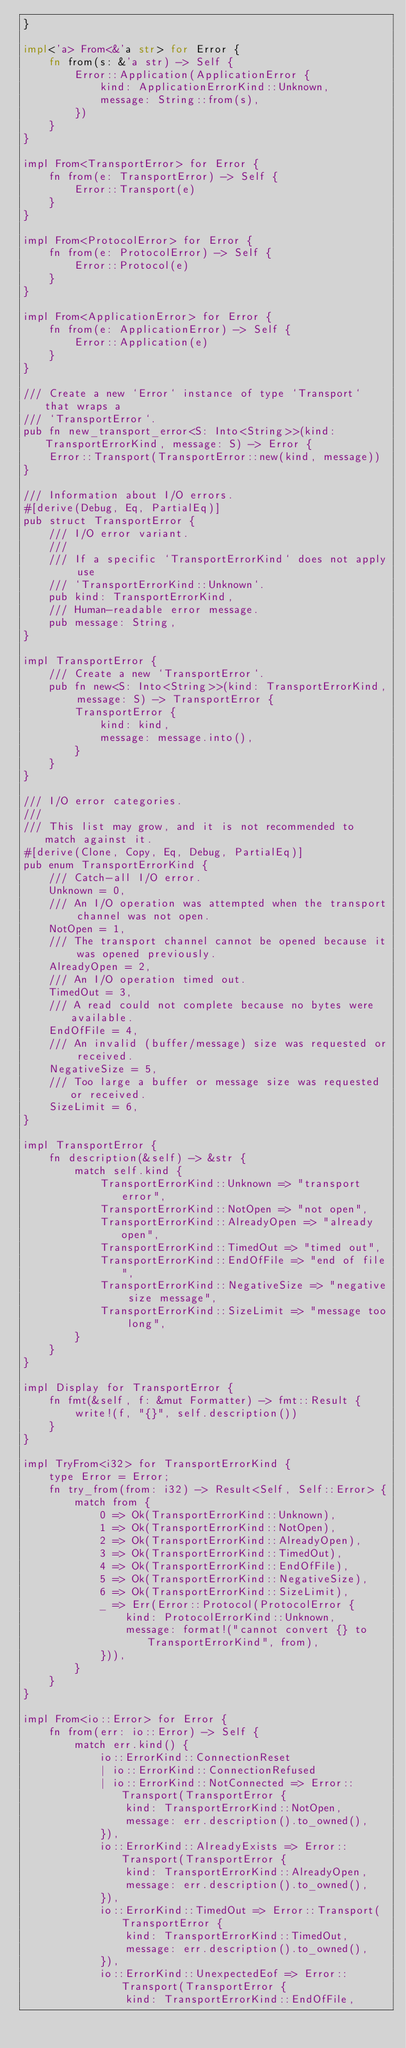<code> <loc_0><loc_0><loc_500><loc_500><_Rust_>}

impl<'a> From<&'a str> for Error {
    fn from(s: &'a str) -> Self {
        Error::Application(ApplicationError {
            kind: ApplicationErrorKind::Unknown,
            message: String::from(s),
        })
    }
}

impl From<TransportError> for Error {
    fn from(e: TransportError) -> Self {
        Error::Transport(e)
    }
}

impl From<ProtocolError> for Error {
    fn from(e: ProtocolError) -> Self {
        Error::Protocol(e)
    }
}

impl From<ApplicationError> for Error {
    fn from(e: ApplicationError) -> Self {
        Error::Application(e)
    }
}

/// Create a new `Error` instance of type `Transport` that wraps a
/// `TransportError`.
pub fn new_transport_error<S: Into<String>>(kind: TransportErrorKind, message: S) -> Error {
    Error::Transport(TransportError::new(kind, message))
}

/// Information about I/O errors.
#[derive(Debug, Eq, PartialEq)]
pub struct TransportError {
    /// I/O error variant.
    ///
    /// If a specific `TransportErrorKind` does not apply use
    /// `TransportErrorKind::Unknown`.
    pub kind: TransportErrorKind,
    /// Human-readable error message.
    pub message: String,
}

impl TransportError {
    /// Create a new `TransportError`.
    pub fn new<S: Into<String>>(kind: TransportErrorKind, message: S) -> TransportError {
        TransportError {
            kind: kind,
            message: message.into(),
        }
    }
}

/// I/O error categories.
///
/// This list may grow, and it is not recommended to match against it.
#[derive(Clone, Copy, Eq, Debug, PartialEq)]
pub enum TransportErrorKind {
    /// Catch-all I/O error.
    Unknown = 0,
    /// An I/O operation was attempted when the transport channel was not open.
    NotOpen = 1,
    /// The transport channel cannot be opened because it was opened previously.
    AlreadyOpen = 2,
    /// An I/O operation timed out.
    TimedOut = 3,
    /// A read could not complete because no bytes were available.
    EndOfFile = 4,
    /// An invalid (buffer/message) size was requested or received.
    NegativeSize = 5,
    /// Too large a buffer or message size was requested or received.
    SizeLimit = 6,
}

impl TransportError {
    fn description(&self) -> &str {
        match self.kind {
            TransportErrorKind::Unknown => "transport error",
            TransportErrorKind::NotOpen => "not open",
            TransportErrorKind::AlreadyOpen => "already open",
            TransportErrorKind::TimedOut => "timed out",
            TransportErrorKind::EndOfFile => "end of file",
            TransportErrorKind::NegativeSize => "negative size message",
            TransportErrorKind::SizeLimit => "message too long",
        }
    }
}

impl Display for TransportError {
    fn fmt(&self, f: &mut Formatter) -> fmt::Result {
        write!(f, "{}", self.description())
    }
}

impl TryFrom<i32> for TransportErrorKind {
    type Error = Error;
    fn try_from(from: i32) -> Result<Self, Self::Error> {
        match from {
            0 => Ok(TransportErrorKind::Unknown),
            1 => Ok(TransportErrorKind::NotOpen),
            2 => Ok(TransportErrorKind::AlreadyOpen),
            3 => Ok(TransportErrorKind::TimedOut),
            4 => Ok(TransportErrorKind::EndOfFile),
            5 => Ok(TransportErrorKind::NegativeSize),
            6 => Ok(TransportErrorKind::SizeLimit),
            _ => Err(Error::Protocol(ProtocolError {
                kind: ProtocolErrorKind::Unknown,
                message: format!("cannot convert {} to TransportErrorKind", from),
            })),
        }
    }
}

impl From<io::Error> for Error {
    fn from(err: io::Error) -> Self {
        match err.kind() {
            io::ErrorKind::ConnectionReset
            | io::ErrorKind::ConnectionRefused
            | io::ErrorKind::NotConnected => Error::Transport(TransportError {
                kind: TransportErrorKind::NotOpen,
                message: err.description().to_owned(),
            }),
            io::ErrorKind::AlreadyExists => Error::Transport(TransportError {
                kind: TransportErrorKind::AlreadyOpen,
                message: err.description().to_owned(),
            }),
            io::ErrorKind::TimedOut => Error::Transport(TransportError {
                kind: TransportErrorKind::TimedOut,
                message: err.description().to_owned(),
            }),
            io::ErrorKind::UnexpectedEof => Error::Transport(TransportError {
                kind: TransportErrorKind::EndOfFile,</code> 